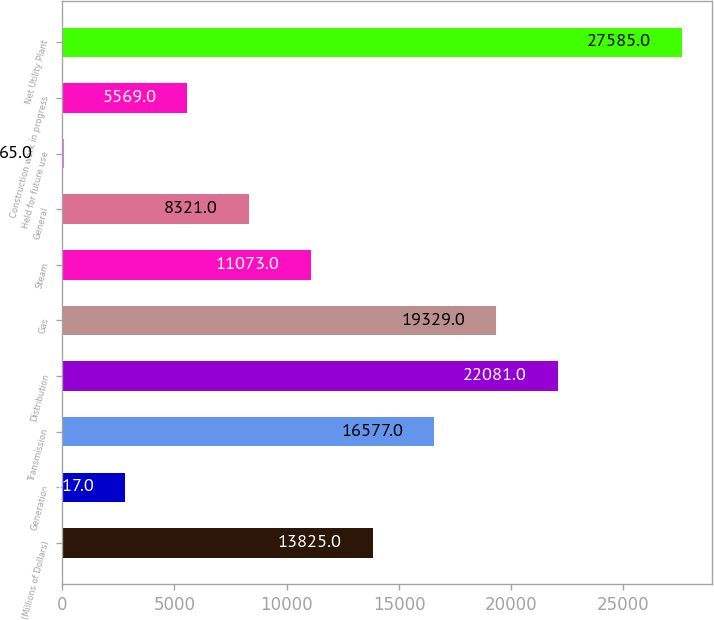<chart> <loc_0><loc_0><loc_500><loc_500><bar_chart><fcel>(Millions of Dollars)<fcel>Generation<fcel>Transmission<fcel>Distribution<fcel>Gas<fcel>Steam<fcel>General<fcel>Held for future use<fcel>Construction work in progress<fcel>Net Utility Plant<nl><fcel>13825<fcel>2817<fcel>16577<fcel>22081<fcel>19329<fcel>11073<fcel>8321<fcel>65<fcel>5569<fcel>27585<nl></chart> 